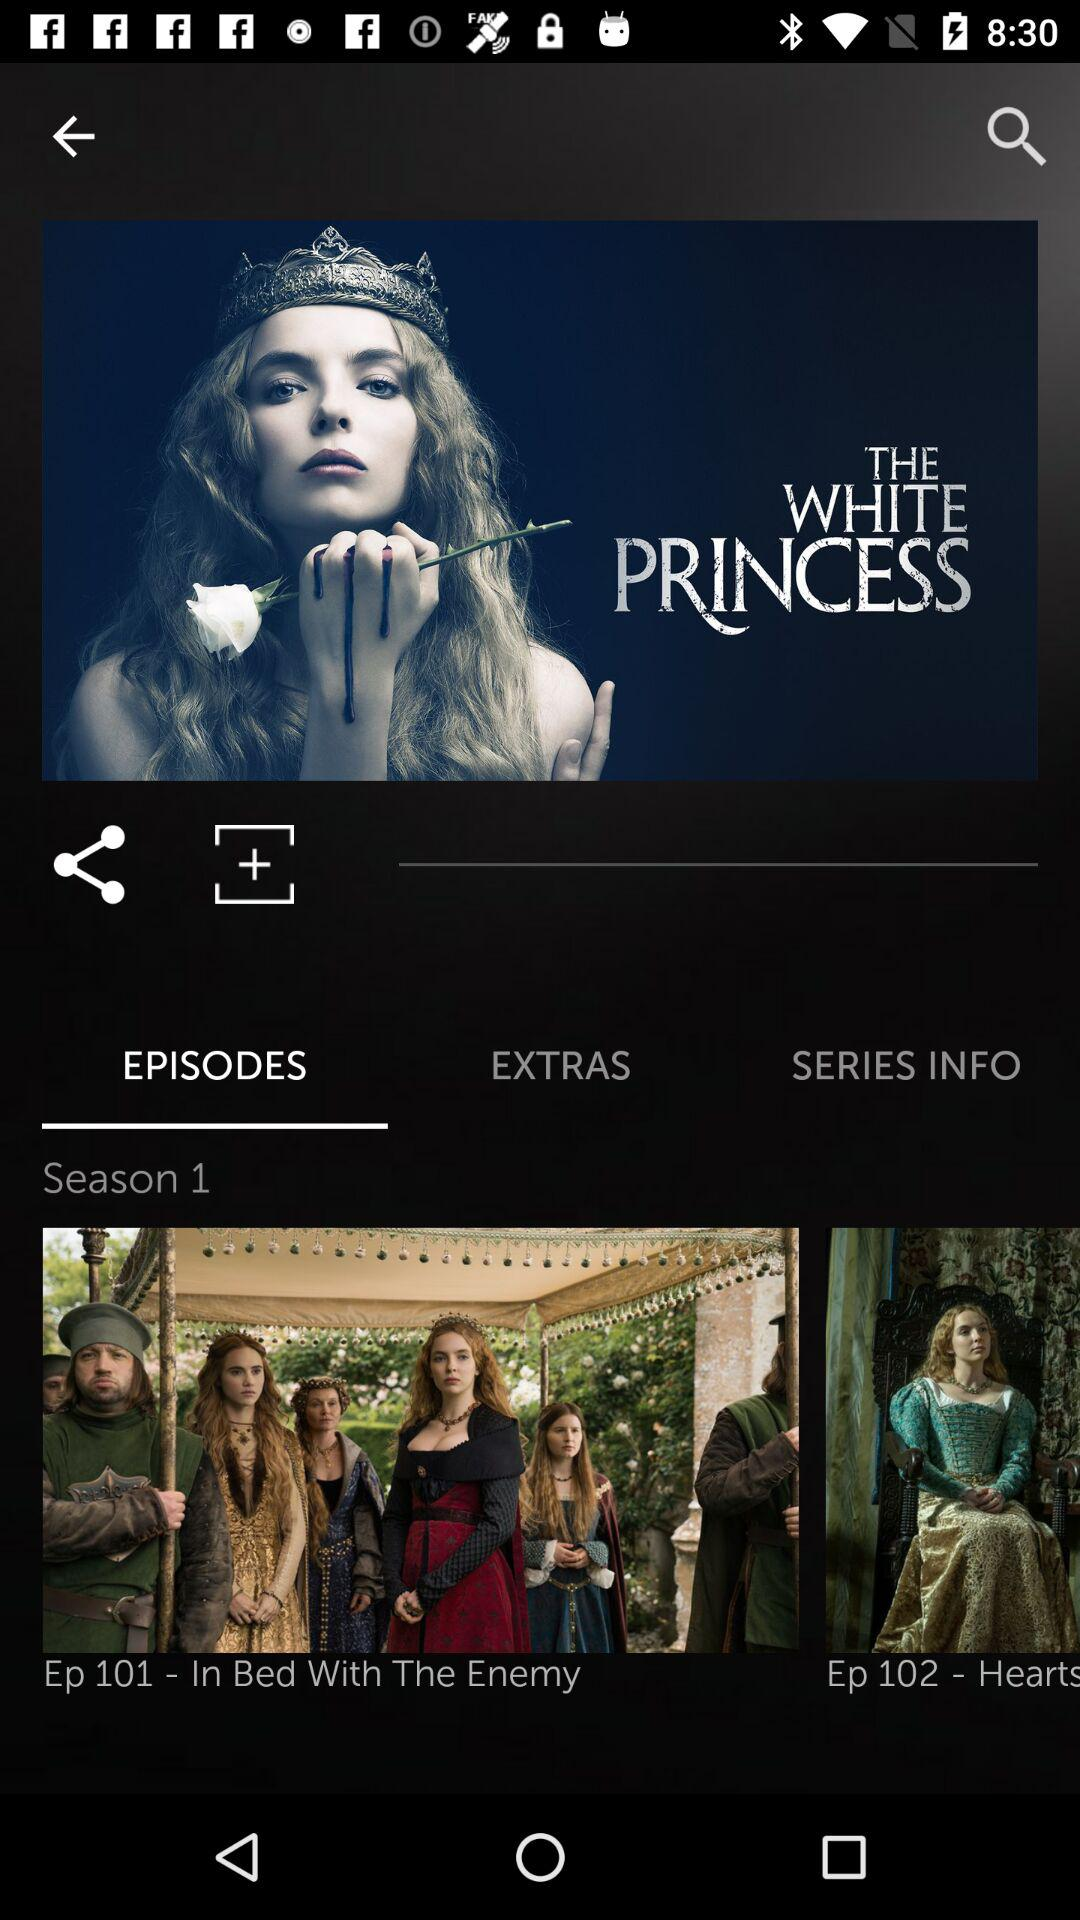What is the series name? The series name is The White Princess. 